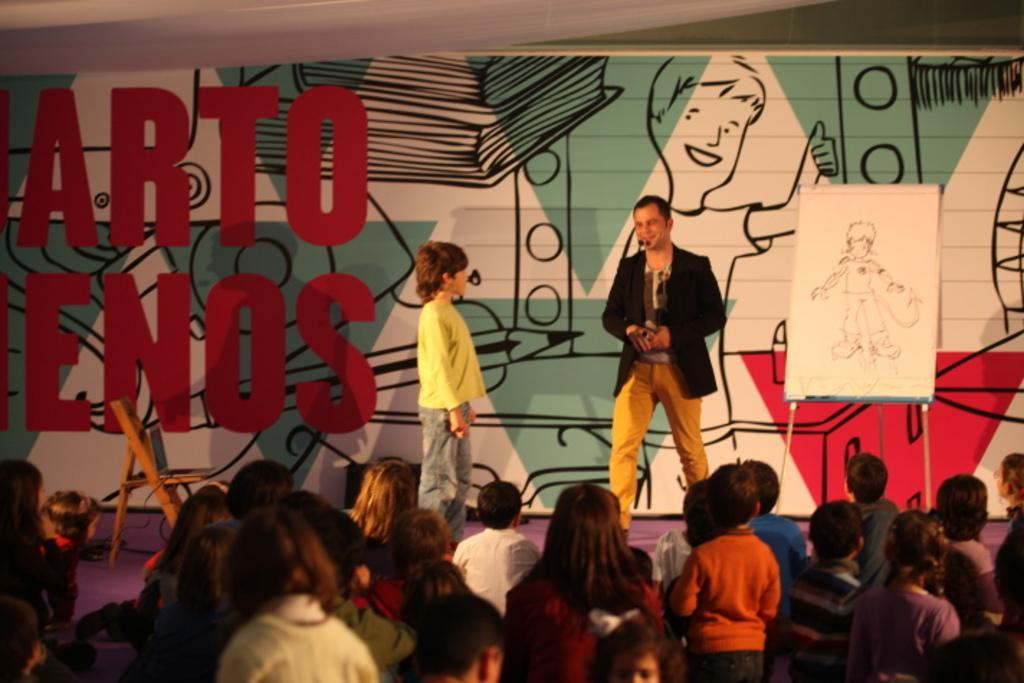What is happening in the image? There are people standing in the image. Can you describe the specific location of the two persons in the image? There are two persons standing on a stage. What can be seen in the background of the image? There are paintings visible in the background of the image. How many dogs are visible in the image? There are no dogs present in the image. What type of eggs are being used in the painting on the stage? There is no mention of eggs in the image or the paintings visible in the background. 